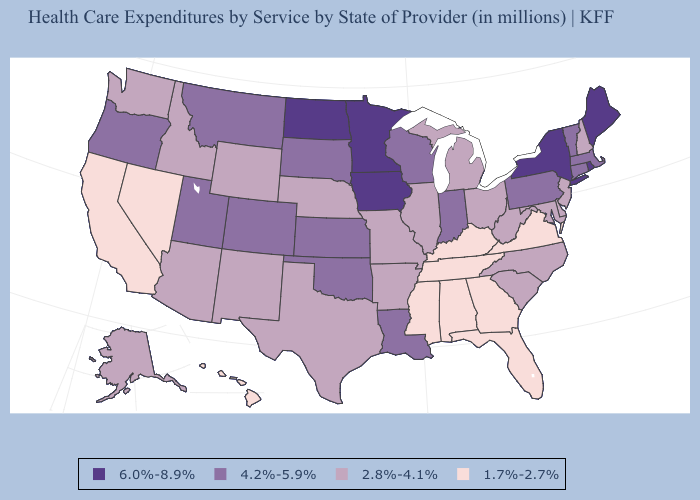Does New Jersey have the highest value in the USA?
Keep it brief. No. Among the states that border Texas , which have the highest value?
Give a very brief answer. Louisiana, Oklahoma. Does North Dakota have the highest value in the USA?
Write a very short answer. Yes. What is the lowest value in the USA?
Concise answer only. 1.7%-2.7%. What is the lowest value in the USA?
Short answer required. 1.7%-2.7%. Name the states that have a value in the range 4.2%-5.9%?
Short answer required. Colorado, Connecticut, Indiana, Kansas, Louisiana, Massachusetts, Montana, Oklahoma, Oregon, Pennsylvania, South Dakota, Utah, Vermont, Wisconsin. Which states hav the highest value in the South?
Keep it brief. Louisiana, Oklahoma. What is the value of Nebraska?
Concise answer only. 2.8%-4.1%. Name the states that have a value in the range 6.0%-8.9%?
Give a very brief answer. Iowa, Maine, Minnesota, New York, North Dakota, Rhode Island. What is the highest value in states that border Montana?
Keep it brief. 6.0%-8.9%. Among the states that border Arizona , which have the highest value?
Be succinct. Colorado, Utah. Name the states that have a value in the range 4.2%-5.9%?
Keep it brief. Colorado, Connecticut, Indiana, Kansas, Louisiana, Massachusetts, Montana, Oklahoma, Oregon, Pennsylvania, South Dakota, Utah, Vermont, Wisconsin. What is the lowest value in states that border Oregon?
Keep it brief. 1.7%-2.7%. Which states hav the highest value in the South?
Short answer required. Louisiana, Oklahoma. Name the states that have a value in the range 4.2%-5.9%?
Be succinct. Colorado, Connecticut, Indiana, Kansas, Louisiana, Massachusetts, Montana, Oklahoma, Oregon, Pennsylvania, South Dakota, Utah, Vermont, Wisconsin. 